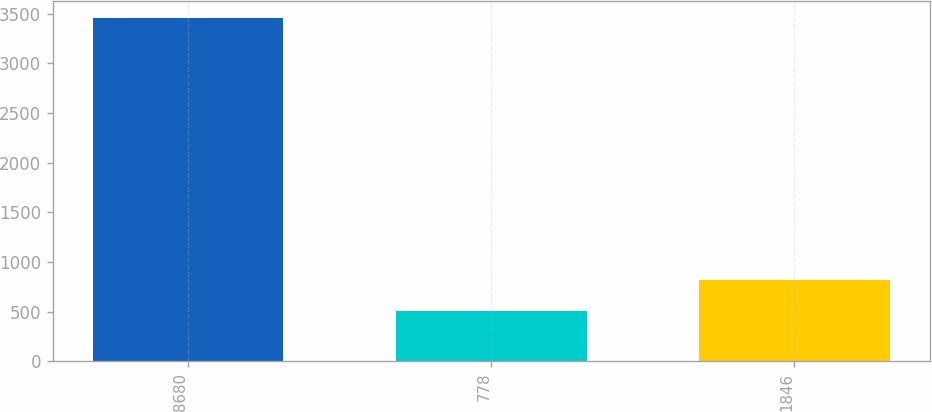Convert chart. <chart><loc_0><loc_0><loc_500><loc_500><bar_chart><fcel>8680<fcel>778<fcel>1846<nl><fcel>3458<fcel>506<fcel>822<nl></chart> 